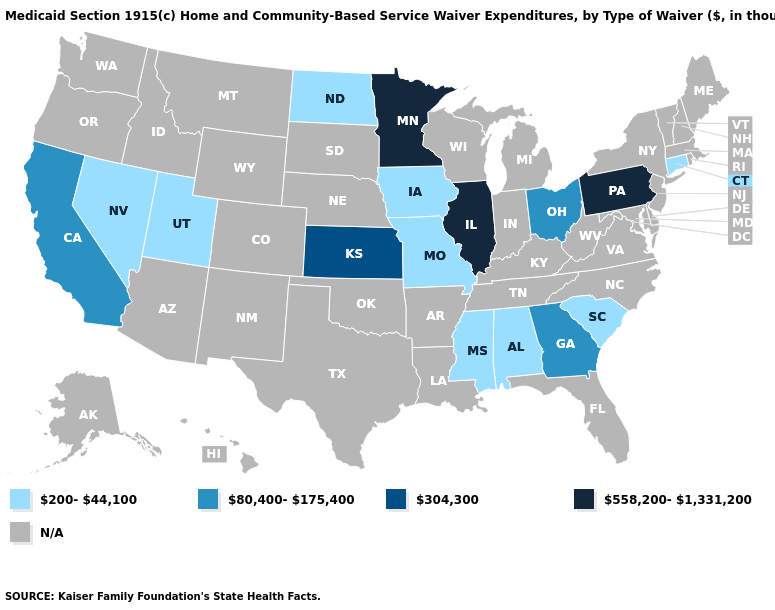What is the value of Maryland?
Concise answer only. N/A. Name the states that have a value in the range 200-44,100?
Short answer required. Alabama, Connecticut, Iowa, Mississippi, Missouri, Nevada, North Dakota, South Carolina, Utah. Among the states that border Florida , does Georgia have the highest value?
Answer briefly. Yes. Name the states that have a value in the range 200-44,100?
Quick response, please. Alabama, Connecticut, Iowa, Mississippi, Missouri, Nevada, North Dakota, South Carolina, Utah. What is the lowest value in the USA?
Answer briefly. 200-44,100. What is the lowest value in the MidWest?
Write a very short answer. 200-44,100. What is the highest value in states that border Missouri?
Be succinct. 558,200-1,331,200. Does the map have missing data?
Quick response, please. Yes. Does Minnesota have the highest value in the USA?
Be succinct. Yes. What is the value of Oklahoma?
Answer briefly. N/A. Does Utah have the highest value in the West?
Concise answer only. No. Does the map have missing data?
Concise answer only. Yes. Is the legend a continuous bar?
Short answer required. No. 